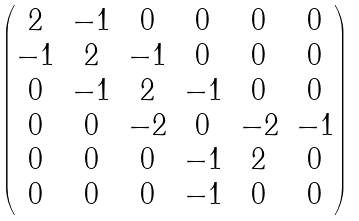<formula> <loc_0><loc_0><loc_500><loc_500>\begin{pmatrix} 2 & - 1 & 0 & 0 & 0 & 0 \\ - 1 & 2 & - 1 & 0 & 0 & 0 \\ 0 & - 1 & 2 & - 1 & 0 & 0 \\ 0 & 0 & - 2 & 0 & - 2 & - 1 \\ 0 & 0 & 0 & - 1 & 2 & 0 \\ 0 & 0 & 0 & - 1 & 0 & 0 \end{pmatrix}</formula> 